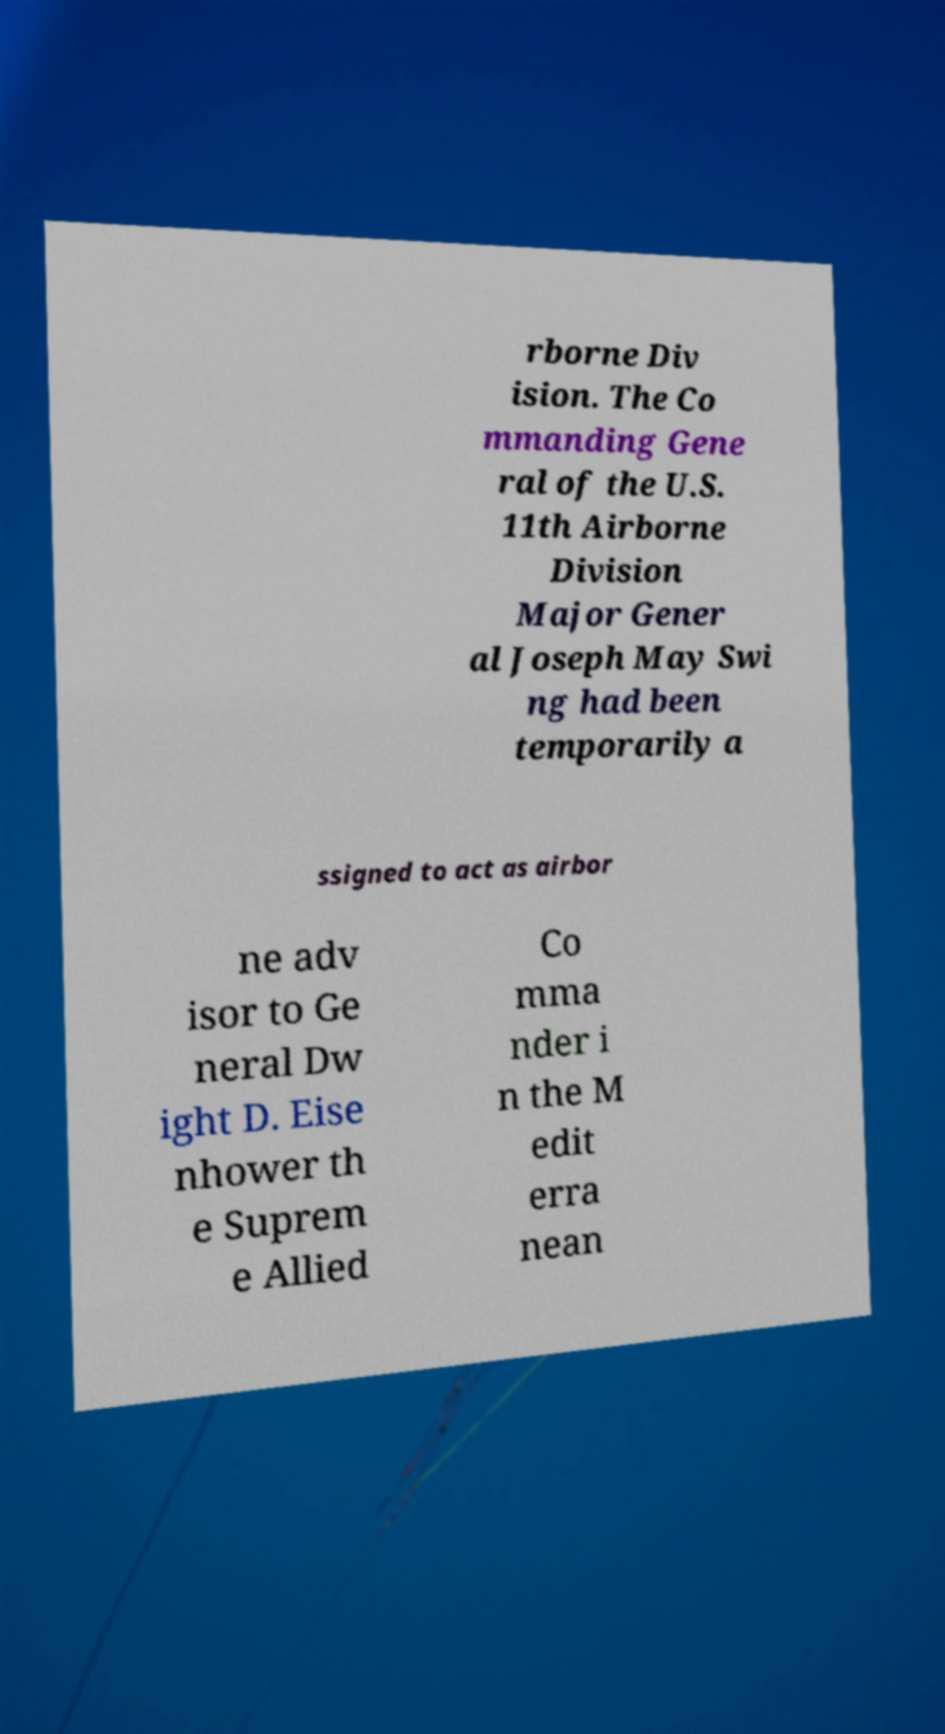Please read and relay the text visible in this image. What does it say? rborne Div ision. The Co mmanding Gene ral of the U.S. 11th Airborne Division Major Gener al Joseph May Swi ng had been temporarily a ssigned to act as airbor ne adv isor to Ge neral Dw ight D. Eise nhower th e Suprem e Allied Co mma nder i n the M edit erra nean 